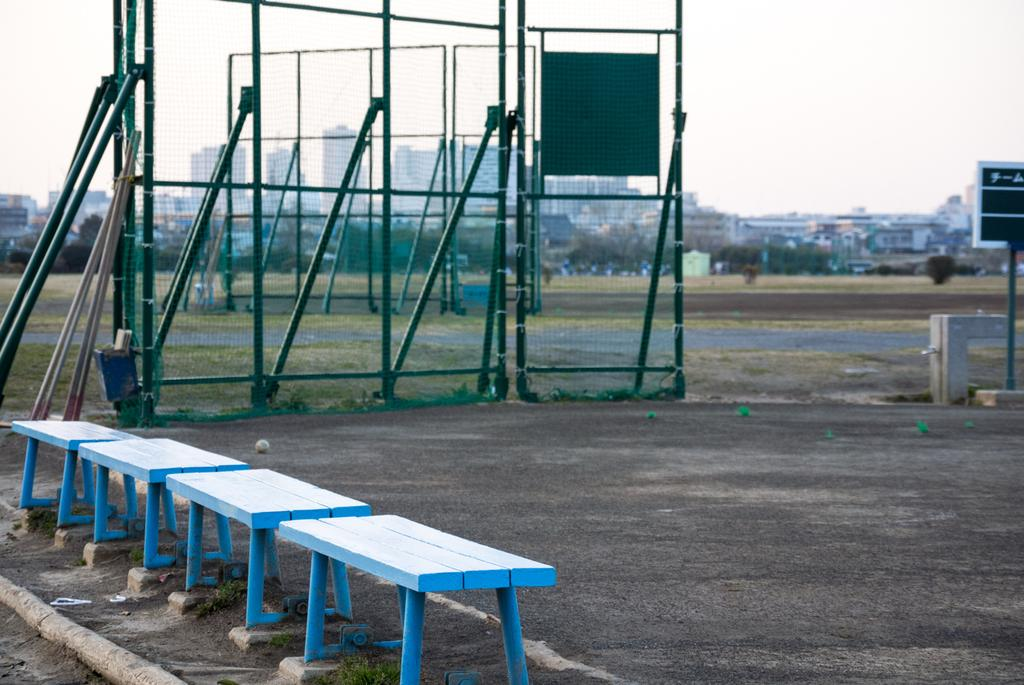What color are the tables in the image? The tables in the image are blue colored. Where are the tables located in the image? The tables are in the left corner of the image. What is beside the tables in the image? There is a green color fence beside the tables. What can be seen in the distance in the image? Buildings are visible in the background of the image. How many items are on the list in the image? There is no list present in the image. What type of smoke can be seen coming from the buildings in the image? There is no smoke visible in the image; only buildings are present in the background. 